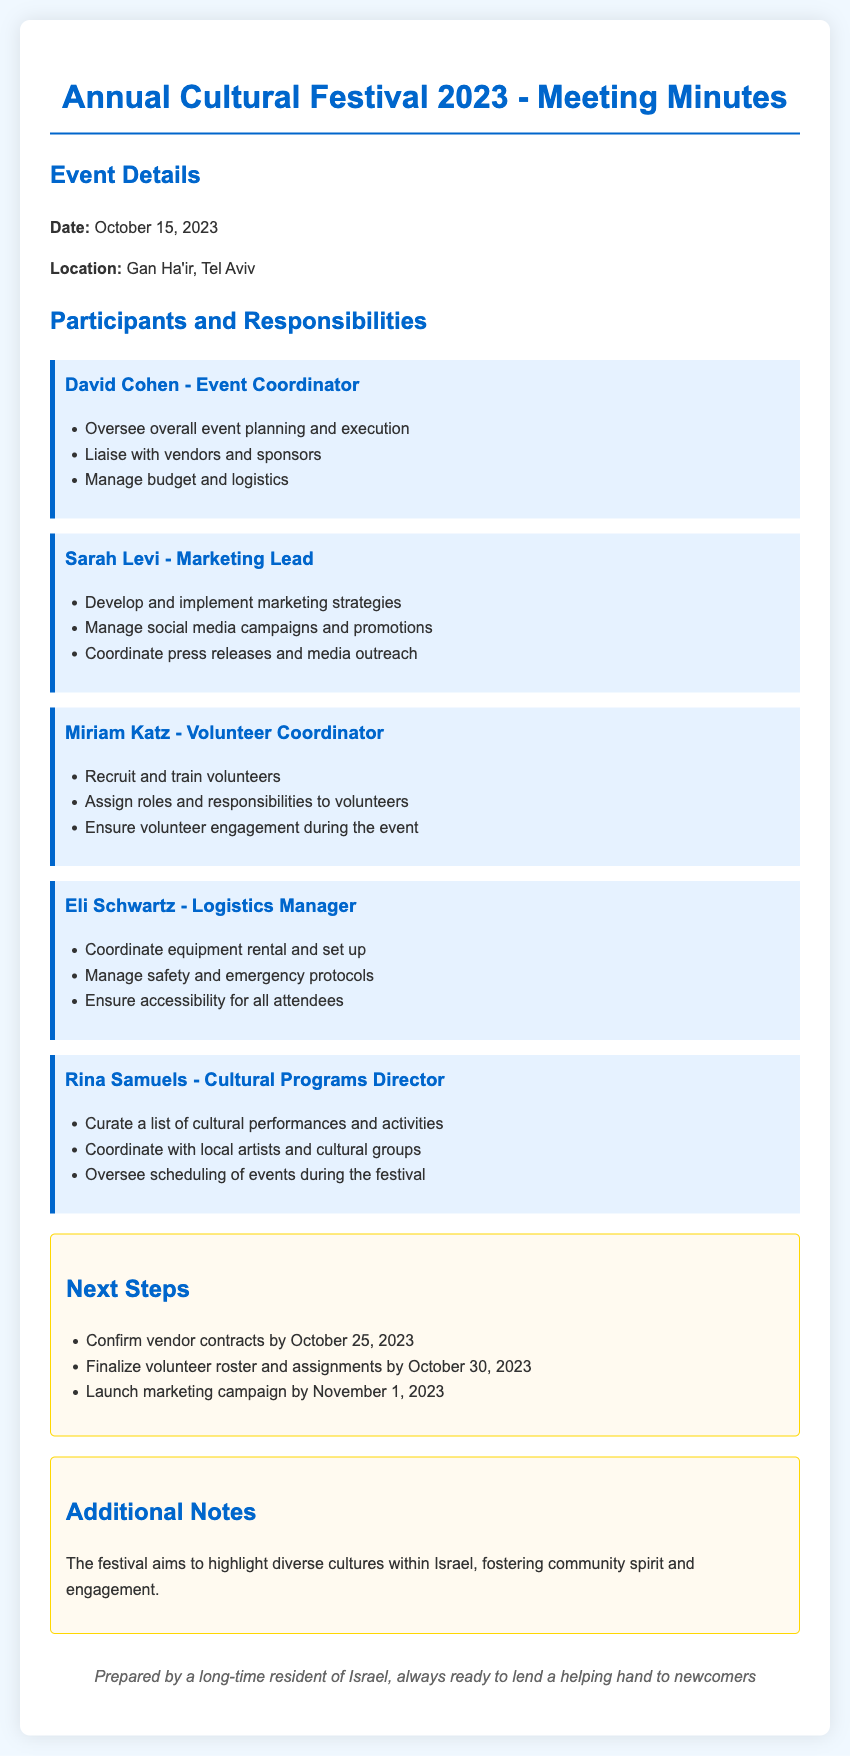what is the date of the festival? The date of the festival is mentioned in the event details section of the document.
Answer: October 15, 2023 who is the Event Coordinator? The role of Event Coordinator is specified under participants and responsibilities.
Answer: David Cohen what is Sarah Levi's role? Sarah Levi's responsibilities are detailed in the participants section, indicating her role.
Answer: Marketing Lead when should vendor contracts be confirmed? This information is found in the next steps section, which outlines key deadlines.
Answer: October 25, 2023 what is the purpose of the cultural festival? The additional notes section explains the festival's aim and its significance.
Answer: Highlight diverse cultures who is responsible for volunteer recruitment? Miriam Katz's responsibilities include recruiting and training volunteers as stated in the document.
Answer: Miriam Katz what is Eli Schwartz in charge of? Eli Schwartz's role is outlined in the participants section, focusing on logistics.
Answer: Logistics Manager by when should the marketing campaign be launched? This deadline is specified in the next steps section of the document.
Answer: November 1, 2023 what type of document is this? The document type can be identified based on its title and content structure.
Answer: Meeting Minutes 